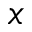<formula> <loc_0><loc_0><loc_500><loc_500>x</formula> 